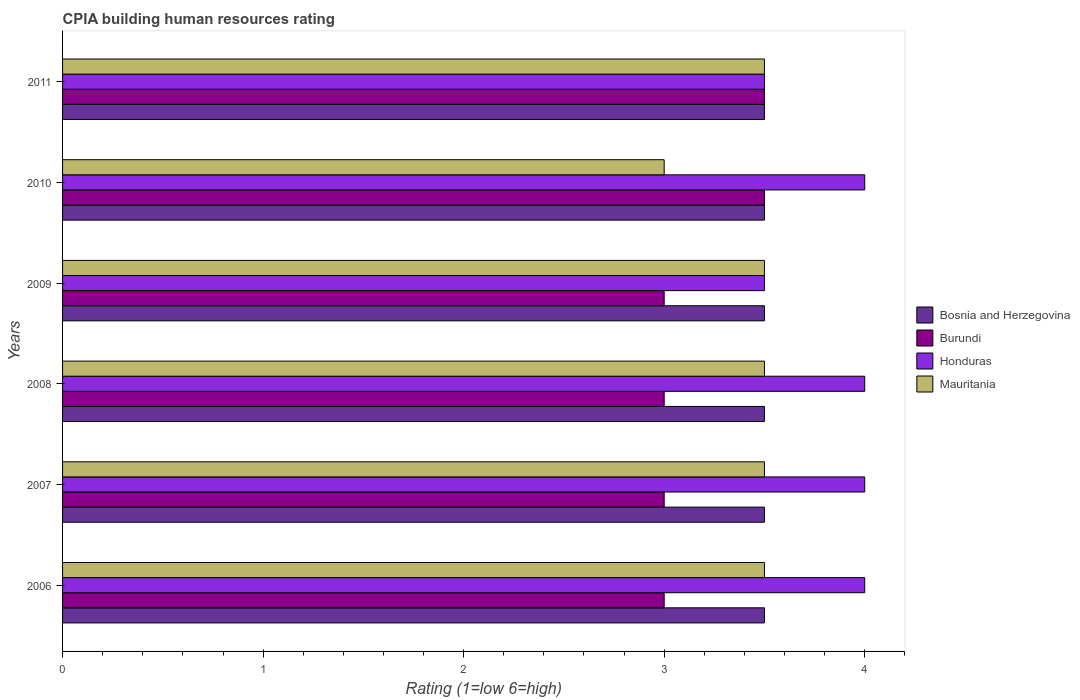How many bars are there on the 4th tick from the top?
Provide a succinct answer. 4. How many bars are there on the 2nd tick from the bottom?
Offer a very short reply. 4. What is the label of the 4th group of bars from the top?
Offer a terse response. 2008. In how many cases, is the number of bars for a given year not equal to the number of legend labels?
Provide a succinct answer. 0. In which year was the CPIA rating in Honduras maximum?
Offer a very short reply. 2006. What is the total CPIA rating in Mauritania in the graph?
Give a very brief answer. 20.5. What is the difference between the CPIA rating in Mauritania in 2007 and that in 2010?
Your answer should be compact. 0.5. What is the average CPIA rating in Burundi per year?
Your answer should be very brief. 3.17. In the year 2008, what is the difference between the CPIA rating in Mauritania and CPIA rating in Bosnia and Herzegovina?
Your response must be concise. 0. Is the difference between the CPIA rating in Mauritania in 2008 and 2010 greater than the difference between the CPIA rating in Bosnia and Herzegovina in 2008 and 2010?
Your answer should be compact. Yes. What is the difference between the highest and the second highest CPIA rating in Mauritania?
Offer a very short reply. 0. What does the 4th bar from the top in 2009 represents?
Keep it short and to the point. Bosnia and Herzegovina. What does the 3rd bar from the bottom in 2007 represents?
Provide a short and direct response. Honduras. Are all the bars in the graph horizontal?
Keep it short and to the point. Yes. What is the difference between two consecutive major ticks on the X-axis?
Your answer should be compact. 1. Does the graph contain any zero values?
Provide a succinct answer. No. Where does the legend appear in the graph?
Make the answer very short. Center right. How many legend labels are there?
Offer a terse response. 4. How are the legend labels stacked?
Make the answer very short. Vertical. What is the title of the graph?
Your answer should be very brief. CPIA building human resources rating. What is the label or title of the X-axis?
Offer a very short reply. Rating (1=low 6=high). What is the label or title of the Y-axis?
Offer a terse response. Years. What is the Rating (1=low 6=high) of Mauritania in 2006?
Your answer should be very brief. 3.5. What is the Rating (1=low 6=high) of Bosnia and Herzegovina in 2007?
Your answer should be compact. 3.5. What is the Rating (1=low 6=high) in Bosnia and Herzegovina in 2008?
Provide a short and direct response. 3.5. What is the Rating (1=low 6=high) of Burundi in 2008?
Give a very brief answer. 3. What is the Rating (1=low 6=high) in Burundi in 2009?
Offer a very short reply. 3. What is the Rating (1=low 6=high) of Bosnia and Herzegovina in 2010?
Make the answer very short. 3.5. What is the Rating (1=low 6=high) in Burundi in 2010?
Provide a succinct answer. 3.5. What is the Rating (1=low 6=high) of Honduras in 2010?
Keep it short and to the point. 4. What is the Rating (1=low 6=high) in Bosnia and Herzegovina in 2011?
Make the answer very short. 3.5. What is the Rating (1=low 6=high) in Burundi in 2011?
Your answer should be very brief. 3.5. What is the Rating (1=low 6=high) of Honduras in 2011?
Your answer should be very brief. 3.5. What is the Rating (1=low 6=high) of Mauritania in 2011?
Your answer should be very brief. 3.5. Across all years, what is the maximum Rating (1=low 6=high) in Bosnia and Herzegovina?
Your answer should be very brief. 3.5. Across all years, what is the maximum Rating (1=low 6=high) in Mauritania?
Your answer should be compact. 3.5. Across all years, what is the minimum Rating (1=low 6=high) of Mauritania?
Give a very brief answer. 3. What is the total Rating (1=low 6=high) of Bosnia and Herzegovina in the graph?
Offer a terse response. 21. What is the difference between the Rating (1=low 6=high) in Mauritania in 2006 and that in 2007?
Make the answer very short. 0. What is the difference between the Rating (1=low 6=high) in Burundi in 2006 and that in 2008?
Provide a short and direct response. 0. What is the difference between the Rating (1=low 6=high) in Honduras in 2006 and that in 2008?
Provide a short and direct response. 0. What is the difference between the Rating (1=low 6=high) of Bosnia and Herzegovina in 2006 and that in 2009?
Provide a short and direct response. 0. What is the difference between the Rating (1=low 6=high) in Burundi in 2006 and that in 2009?
Make the answer very short. 0. What is the difference between the Rating (1=low 6=high) of Mauritania in 2006 and that in 2009?
Provide a succinct answer. 0. What is the difference between the Rating (1=low 6=high) of Bosnia and Herzegovina in 2006 and that in 2010?
Keep it short and to the point. 0. What is the difference between the Rating (1=low 6=high) of Bosnia and Herzegovina in 2006 and that in 2011?
Give a very brief answer. 0. What is the difference between the Rating (1=low 6=high) in Burundi in 2006 and that in 2011?
Your response must be concise. -0.5. What is the difference between the Rating (1=low 6=high) in Bosnia and Herzegovina in 2007 and that in 2008?
Make the answer very short. 0. What is the difference between the Rating (1=low 6=high) in Bosnia and Herzegovina in 2007 and that in 2010?
Provide a succinct answer. 0. What is the difference between the Rating (1=low 6=high) in Bosnia and Herzegovina in 2007 and that in 2011?
Offer a terse response. 0. What is the difference between the Rating (1=low 6=high) of Honduras in 2007 and that in 2011?
Ensure brevity in your answer.  0.5. What is the difference between the Rating (1=low 6=high) of Burundi in 2008 and that in 2009?
Your response must be concise. 0. What is the difference between the Rating (1=low 6=high) of Honduras in 2008 and that in 2009?
Your answer should be compact. 0.5. What is the difference between the Rating (1=low 6=high) of Bosnia and Herzegovina in 2008 and that in 2010?
Your response must be concise. 0. What is the difference between the Rating (1=low 6=high) in Burundi in 2008 and that in 2010?
Your response must be concise. -0.5. What is the difference between the Rating (1=low 6=high) in Honduras in 2008 and that in 2010?
Your answer should be very brief. 0. What is the difference between the Rating (1=low 6=high) of Mauritania in 2008 and that in 2010?
Your answer should be compact. 0.5. What is the difference between the Rating (1=low 6=high) in Burundi in 2008 and that in 2011?
Give a very brief answer. -0.5. What is the difference between the Rating (1=low 6=high) in Honduras in 2008 and that in 2011?
Keep it short and to the point. 0.5. What is the difference between the Rating (1=low 6=high) in Mauritania in 2008 and that in 2011?
Provide a succinct answer. 0. What is the difference between the Rating (1=low 6=high) in Burundi in 2009 and that in 2010?
Give a very brief answer. -0.5. What is the difference between the Rating (1=low 6=high) of Burundi in 2009 and that in 2011?
Your answer should be very brief. -0.5. What is the difference between the Rating (1=low 6=high) in Mauritania in 2009 and that in 2011?
Keep it short and to the point. 0. What is the difference between the Rating (1=low 6=high) of Burundi in 2010 and that in 2011?
Your answer should be very brief. 0. What is the difference between the Rating (1=low 6=high) in Bosnia and Herzegovina in 2006 and the Rating (1=low 6=high) in Honduras in 2007?
Your response must be concise. -0.5. What is the difference between the Rating (1=low 6=high) in Bosnia and Herzegovina in 2006 and the Rating (1=low 6=high) in Mauritania in 2007?
Keep it short and to the point. 0. What is the difference between the Rating (1=low 6=high) of Bosnia and Herzegovina in 2006 and the Rating (1=low 6=high) of Honduras in 2008?
Make the answer very short. -0.5. What is the difference between the Rating (1=low 6=high) of Burundi in 2006 and the Rating (1=low 6=high) of Honduras in 2008?
Provide a short and direct response. -1. What is the difference between the Rating (1=low 6=high) of Bosnia and Herzegovina in 2006 and the Rating (1=low 6=high) of Burundi in 2009?
Offer a very short reply. 0.5. What is the difference between the Rating (1=low 6=high) in Bosnia and Herzegovina in 2006 and the Rating (1=low 6=high) in Honduras in 2009?
Offer a very short reply. 0. What is the difference between the Rating (1=low 6=high) of Burundi in 2006 and the Rating (1=low 6=high) of Honduras in 2009?
Provide a succinct answer. -0.5. What is the difference between the Rating (1=low 6=high) in Burundi in 2006 and the Rating (1=low 6=high) in Mauritania in 2009?
Your answer should be very brief. -0.5. What is the difference between the Rating (1=low 6=high) in Bosnia and Herzegovina in 2006 and the Rating (1=low 6=high) in Honduras in 2010?
Keep it short and to the point. -0.5. What is the difference between the Rating (1=low 6=high) in Bosnia and Herzegovina in 2006 and the Rating (1=low 6=high) in Mauritania in 2010?
Provide a succinct answer. 0.5. What is the difference between the Rating (1=low 6=high) in Burundi in 2006 and the Rating (1=low 6=high) in Mauritania in 2010?
Make the answer very short. 0. What is the difference between the Rating (1=low 6=high) in Honduras in 2006 and the Rating (1=low 6=high) in Mauritania in 2010?
Offer a very short reply. 1. What is the difference between the Rating (1=low 6=high) in Bosnia and Herzegovina in 2006 and the Rating (1=low 6=high) in Burundi in 2011?
Ensure brevity in your answer.  0. What is the difference between the Rating (1=low 6=high) in Bosnia and Herzegovina in 2006 and the Rating (1=low 6=high) in Mauritania in 2011?
Give a very brief answer. 0. What is the difference between the Rating (1=low 6=high) in Burundi in 2006 and the Rating (1=low 6=high) in Mauritania in 2011?
Provide a short and direct response. -0.5. What is the difference between the Rating (1=low 6=high) in Bosnia and Herzegovina in 2007 and the Rating (1=low 6=high) in Burundi in 2008?
Ensure brevity in your answer.  0.5. What is the difference between the Rating (1=low 6=high) of Bosnia and Herzegovina in 2007 and the Rating (1=low 6=high) of Honduras in 2008?
Your response must be concise. -0.5. What is the difference between the Rating (1=low 6=high) of Bosnia and Herzegovina in 2007 and the Rating (1=low 6=high) of Mauritania in 2008?
Offer a terse response. 0. What is the difference between the Rating (1=low 6=high) in Burundi in 2007 and the Rating (1=low 6=high) in Mauritania in 2008?
Provide a short and direct response. -0.5. What is the difference between the Rating (1=low 6=high) of Bosnia and Herzegovina in 2007 and the Rating (1=low 6=high) of Burundi in 2009?
Offer a very short reply. 0.5. What is the difference between the Rating (1=low 6=high) in Bosnia and Herzegovina in 2007 and the Rating (1=low 6=high) in Honduras in 2009?
Your answer should be compact. 0. What is the difference between the Rating (1=low 6=high) of Honduras in 2007 and the Rating (1=low 6=high) of Mauritania in 2009?
Offer a terse response. 0.5. What is the difference between the Rating (1=low 6=high) in Bosnia and Herzegovina in 2007 and the Rating (1=low 6=high) in Mauritania in 2010?
Give a very brief answer. 0.5. What is the difference between the Rating (1=low 6=high) in Burundi in 2007 and the Rating (1=low 6=high) in Honduras in 2010?
Your answer should be very brief. -1. What is the difference between the Rating (1=low 6=high) of Bosnia and Herzegovina in 2007 and the Rating (1=low 6=high) of Mauritania in 2011?
Provide a succinct answer. 0. What is the difference between the Rating (1=low 6=high) in Burundi in 2007 and the Rating (1=low 6=high) in Mauritania in 2011?
Make the answer very short. -0.5. What is the difference between the Rating (1=low 6=high) of Honduras in 2007 and the Rating (1=low 6=high) of Mauritania in 2011?
Make the answer very short. 0.5. What is the difference between the Rating (1=low 6=high) in Bosnia and Herzegovina in 2008 and the Rating (1=low 6=high) in Burundi in 2009?
Your answer should be very brief. 0.5. What is the difference between the Rating (1=low 6=high) of Bosnia and Herzegovina in 2008 and the Rating (1=low 6=high) of Honduras in 2009?
Offer a terse response. 0. What is the difference between the Rating (1=low 6=high) in Burundi in 2008 and the Rating (1=low 6=high) in Honduras in 2009?
Provide a succinct answer. -0.5. What is the difference between the Rating (1=low 6=high) in Honduras in 2008 and the Rating (1=low 6=high) in Mauritania in 2009?
Give a very brief answer. 0.5. What is the difference between the Rating (1=low 6=high) of Bosnia and Herzegovina in 2008 and the Rating (1=low 6=high) of Honduras in 2010?
Provide a succinct answer. -0.5. What is the difference between the Rating (1=low 6=high) of Burundi in 2008 and the Rating (1=low 6=high) of Honduras in 2010?
Keep it short and to the point. -1. What is the difference between the Rating (1=low 6=high) of Burundi in 2008 and the Rating (1=low 6=high) of Mauritania in 2011?
Keep it short and to the point. -0.5. What is the difference between the Rating (1=low 6=high) in Honduras in 2008 and the Rating (1=low 6=high) in Mauritania in 2011?
Offer a very short reply. 0.5. What is the difference between the Rating (1=low 6=high) in Bosnia and Herzegovina in 2009 and the Rating (1=low 6=high) in Honduras in 2010?
Provide a short and direct response. -0.5. What is the difference between the Rating (1=low 6=high) of Bosnia and Herzegovina in 2009 and the Rating (1=low 6=high) of Mauritania in 2010?
Offer a terse response. 0.5. What is the difference between the Rating (1=low 6=high) of Honduras in 2009 and the Rating (1=low 6=high) of Mauritania in 2010?
Offer a terse response. 0.5. What is the difference between the Rating (1=low 6=high) of Bosnia and Herzegovina in 2009 and the Rating (1=low 6=high) of Honduras in 2011?
Offer a terse response. 0. What is the difference between the Rating (1=low 6=high) of Bosnia and Herzegovina in 2009 and the Rating (1=low 6=high) of Mauritania in 2011?
Your response must be concise. 0. What is the difference between the Rating (1=low 6=high) of Burundi in 2009 and the Rating (1=low 6=high) of Mauritania in 2011?
Your response must be concise. -0.5. What is the difference between the Rating (1=low 6=high) of Bosnia and Herzegovina in 2010 and the Rating (1=low 6=high) of Burundi in 2011?
Make the answer very short. 0. What is the difference between the Rating (1=low 6=high) of Bosnia and Herzegovina in 2010 and the Rating (1=low 6=high) of Mauritania in 2011?
Your answer should be compact. 0. What is the average Rating (1=low 6=high) in Burundi per year?
Offer a very short reply. 3.17. What is the average Rating (1=low 6=high) in Honduras per year?
Give a very brief answer. 3.83. What is the average Rating (1=low 6=high) in Mauritania per year?
Offer a very short reply. 3.42. In the year 2006, what is the difference between the Rating (1=low 6=high) of Bosnia and Herzegovina and Rating (1=low 6=high) of Burundi?
Keep it short and to the point. 0.5. In the year 2006, what is the difference between the Rating (1=low 6=high) of Bosnia and Herzegovina and Rating (1=low 6=high) of Honduras?
Provide a short and direct response. -0.5. In the year 2006, what is the difference between the Rating (1=low 6=high) of Burundi and Rating (1=low 6=high) of Honduras?
Your answer should be compact. -1. In the year 2007, what is the difference between the Rating (1=low 6=high) in Bosnia and Herzegovina and Rating (1=low 6=high) in Honduras?
Offer a very short reply. -0.5. In the year 2007, what is the difference between the Rating (1=low 6=high) in Bosnia and Herzegovina and Rating (1=low 6=high) in Mauritania?
Keep it short and to the point. 0. In the year 2007, what is the difference between the Rating (1=low 6=high) of Burundi and Rating (1=low 6=high) of Honduras?
Make the answer very short. -1. In the year 2008, what is the difference between the Rating (1=low 6=high) in Bosnia and Herzegovina and Rating (1=low 6=high) in Burundi?
Your response must be concise. 0.5. In the year 2008, what is the difference between the Rating (1=low 6=high) in Bosnia and Herzegovina and Rating (1=low 6=high) in Honduras?
Offer a terse response. -0.5. In the year 2008, what is the difference between the Rating (1=low 6=high) of Burundi and Rating (1=low 6=high) of Mauritania?
Make the answer very short. -0.5. In the year 2009, what is the difference between the Rating (1=low 6=high) of Bosnia and Herzegovina and Rating (1=low 6=high) of Burundi?
Offer a terse response. 0.5. In the year 2009, what is the difference between the Rating (1=low 6=high) of Bosnia and Herzegovina and Rating (1=low 6=high) of Honduras?
Your answer should be very brief. 0. In the year 2009, what is the difference between the Rating (1=low 6=high) of Honduras and Rating (1=low 6=high) of Mauritania?
Your answer should be compact. 0. In the year 2010, what is the difference between the Rating (1=low 6=high) of Bosnia and Herzegovina and Rating (1=low 6=high) of Burundi?
Your response must be concise. 0. In the year 2010, what is the difference between the Rating (1=low 6=high) in Burundi and Rating (1=low 6=high) in Honduras?
Your answer should be very brief. -0.5. In the year 2010, what is the difference between the Rating (1=low 6=high) in Burundi and Rating (1=low 6=high) in Mauritania?
Offer a very short reply. 0.5. In the year 2010, what is the difference between the Rating (1=low 6=high) in Honduras and Rating (1=low 6=high) in Mauritania?
Your response must be concise. 1. In the year 2011, what is the difference between the Rating (1=low 6=high) of Bosnia and Herzegovina and Rating (1=low 6=high) of Mauritania?
Your answer should be very brief. 0. In the year 2011, what is the difference between the Rating (1=low 6=high) of Burundi and Rating (1=low 6=high) of Honduras?
Offer a very short reply. 0. In the year 2011, what is the difference between the Rating (1=low 6=high) of Burundi and Rating (1=low 6=high) of Mauritania?
Make the answer very short. 0. What is the ratio of the Rating (1=low 6=high) of Bosnia and Herzegovina in 2006 to that in 2007?
Your response must be concise. 1. What is the ratio of the Rating (1=low 6=high) of Burundi in 2006 to that in 2007?
Ensure brevity in your answer.  1. What is the ratio of the Rating (1=low 6=high) of Mauritania in 2006 to that in 2007?
Offer a very short reply. 1. What is the ratio of the Rating (1=low 6=high) in Burundi in 2006 to that in 2008?
Provide a succinct answer. 1. What is the ratio of the Rating (1=low 6=high) of Honduras in 2006 to that in 2008?
Make the answer very short. 1. What is the ratio of the Rating (1=low 6=high) in Mauritania in 2006 to that in 2008?
Your answer should be very brief. 1. What is the ratio of the Rating (1=low 6=high) of Burundi in 2006 to that in 2009?
Provide a short and direct response. 1. What is the ratio of the Rating (1=low 6=high) in Honduras in 2006 to that in 2009?
Keep it short and to the point. 1.14. What is the ratio of the Rating (1=low 6=high) of Mauritania in 2006 to that in 2010?
Make the answer very short. 1.17. What is the ratio of the Rating (1=low 6=high) in Bosnia and Herzegovina in 2006 to that in 2011?
Keep it short and to the point. 1. What is the ratio of the Rating (1=low 6=high) of Burundi in 2006 to that in 2011?
Your answer should be very brief. 0.86. What is the ratio of the Rating (1=low 6=high) in Honduras in 2006 to that in 2011?
Make the answer very short. 1.14. What is the ratio of the Rating (1=low 6=high) in Burundi in 2007 to that in 2008?
Provide a short and direct response. 1. What is the ratio of the Rating (1=low 6=high) of Honduras in 2007 to that in 2008?
Keep it short and to the point. 1. What is the ratio of the Rating (1=low 6=high) in Mauritania in 2007 to that in 2008?
Offer a terse response. 1. What is the ratio of the Rating (1=low 6=high) of Bosnia and Herzegovina in 2007 to that in 2009?
Give a very brief answer. 1. What is the ratio of the Rating (1=low 6=high) in Mauritania in 2007 to that in 2009?
Keep it short and to the point. 1. What is the ratio of the Rating (1=low 6=high) in Burundi in 2007 to that in 2010?
Ensure brevity in your answer.  0.86. What is the ratio of the Rating (1=low 6=high) in Mauritania in 2007 to that in 2010?
Your answer should be very brief. 1.17. What is the ratio of the Rating (1=low 6=high) in Burundi in 2007 to that in 2011?
Your response must be concise. 0.86. What is the ratio of the Rating (1=low 6=high) of Honduras in 2007 to that in 2011?
Give a very brief answer. 1.14. What is the ratio of the Rating (1=low 6=high) in Bosnia and Herzegovina in 2008 to that in 2009?
Your response must be concise. 1. What is the ratio of the Rating (1=low 6=high) of Burundi in 2008 to that in 2009?
Offer a very short reply. 1. What is the ratio of the Rating (1=low 6=high) of Burundi in 2008 to that in 2010?
Keep it short and to the point. 0.86. What is the ratio of the Rating (1=low 6=high) in Bosnia and Herzegovina in 2008 to that in 2011?
Your response must be concise. 1. What is the ratio of the Rating (1=low 6=high) in Mauritania in 2008 to that in 2011?
Your answer should be compact. 1. What is the ratio of the Rating (1=low 6=high) in Burundi in 2009 to that in 2011?
Your answer should be compact. 0.86. What is the ratio of the Rating (1=low 6=high) in Honduras in 2010 to that in 2011?
Keep it short and to the point. 1.14. What is the ratio of the Rating (1=low 6=high) of Mauritania in 2010 to that in 2011?
Keep it short and to the point. 0.86. What is the difference between the highest and the second highest Rating (1=low 6=high) in Burundi?
Your answer should be very brief. 0. What is the difference between the highest and the lowest Rating (1=low 6=high) of Honduras?
Ensure brevity in your answer.  0.5. What is the difference between the highest and the lowest Rating (1=low 6=high) of Mauritania?
Provide a short and direct response. 0.5. 